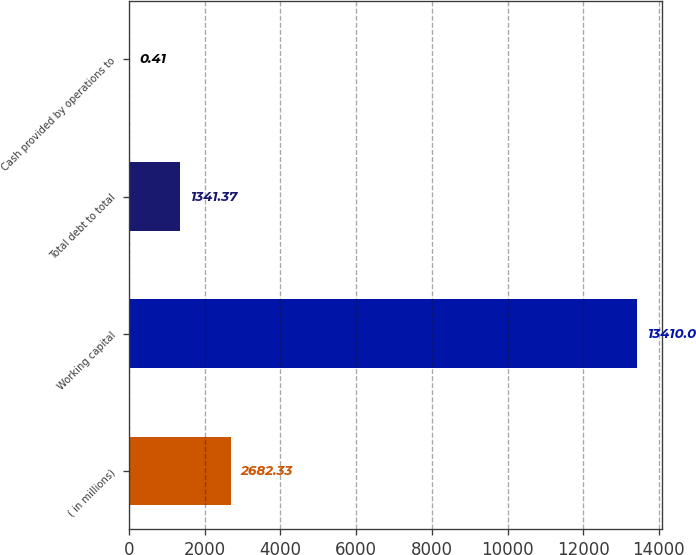Convert chart. <chart><loc_0><loc_0><loc_500><loc_500><bar_chart><fcel>( in millions)<fcel>Working capital<fcel>Total debt to total<fcel>Cash provided by operations to<nl><fcel>2682.33<fcel>13410<fcel>1341.37<fcel>0.41<nl></chart> 